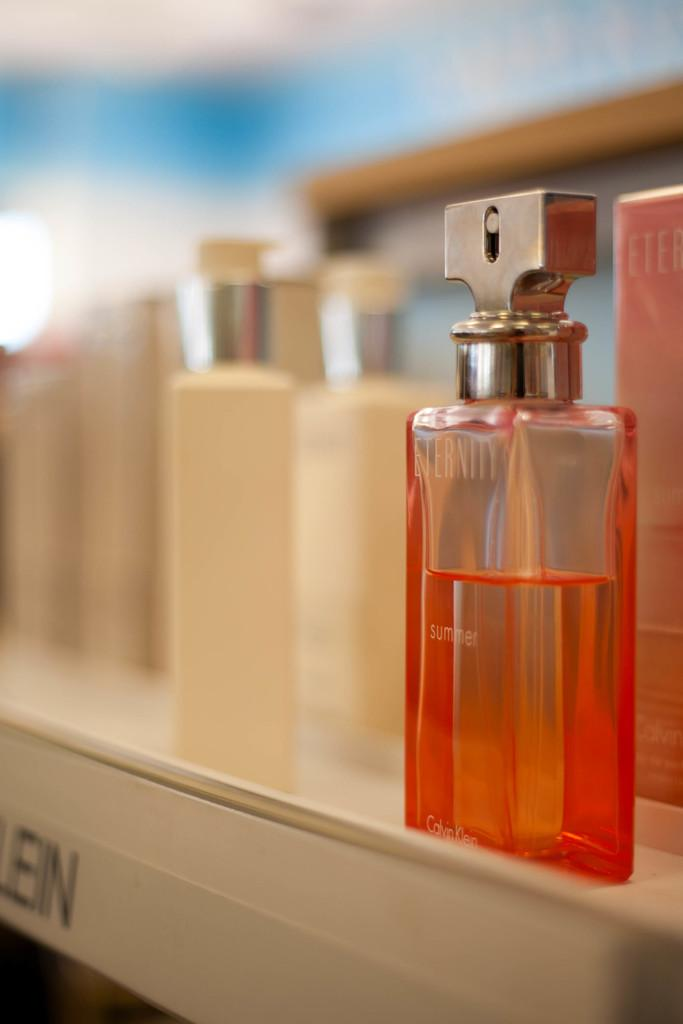<image>
Give a short and clear explanation of the subsequent image. Orange bottle of Eternity with a silver cap on top of a shelf. 